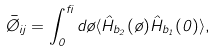Convert formula to latex. <formula><loc_0><loc_0><loc_500><loc_500>\bar { \chi } _ { i j } = \int _ { 0 } ^ { \beta } d \tau \langle \hat { H } _ { b _ { 2 } } ( \tau ) \hat { H } _ { b _ { 1 } } ( 0 ) \rangle ,</formula> 